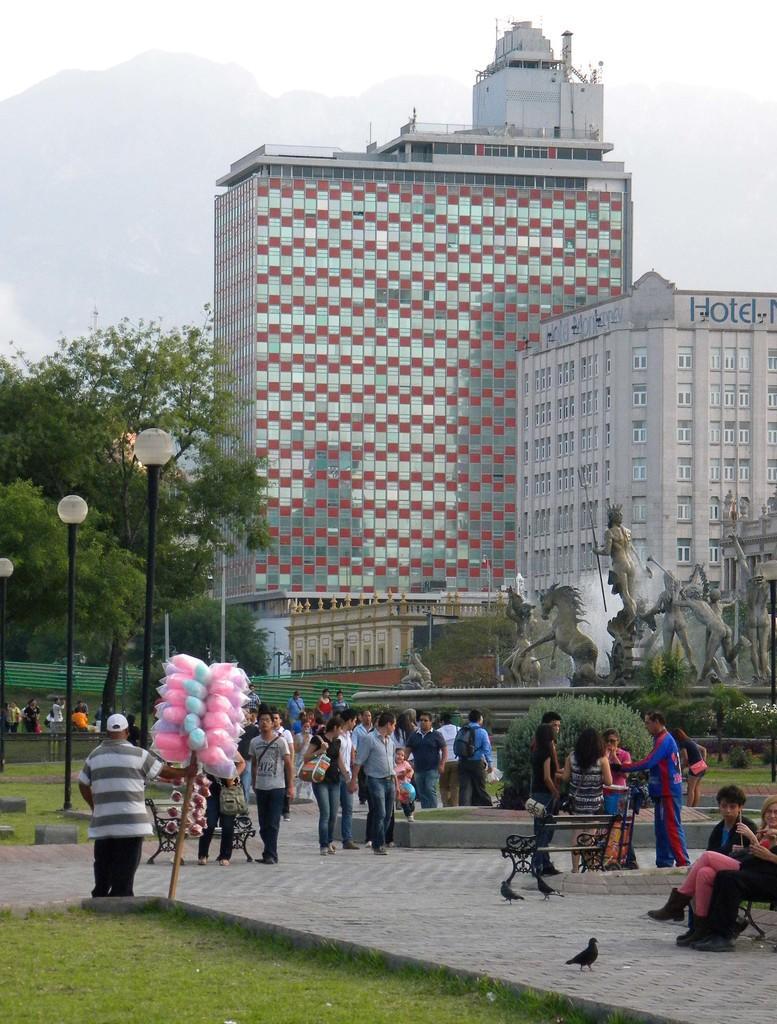How would you summarize this image in a sentence or two? This picture describes about group of people, few are seated, few are standing and few are walking, in the background we can see few poles, lights, trees, buildings, statues and water fountain, and also we can see a bird. 